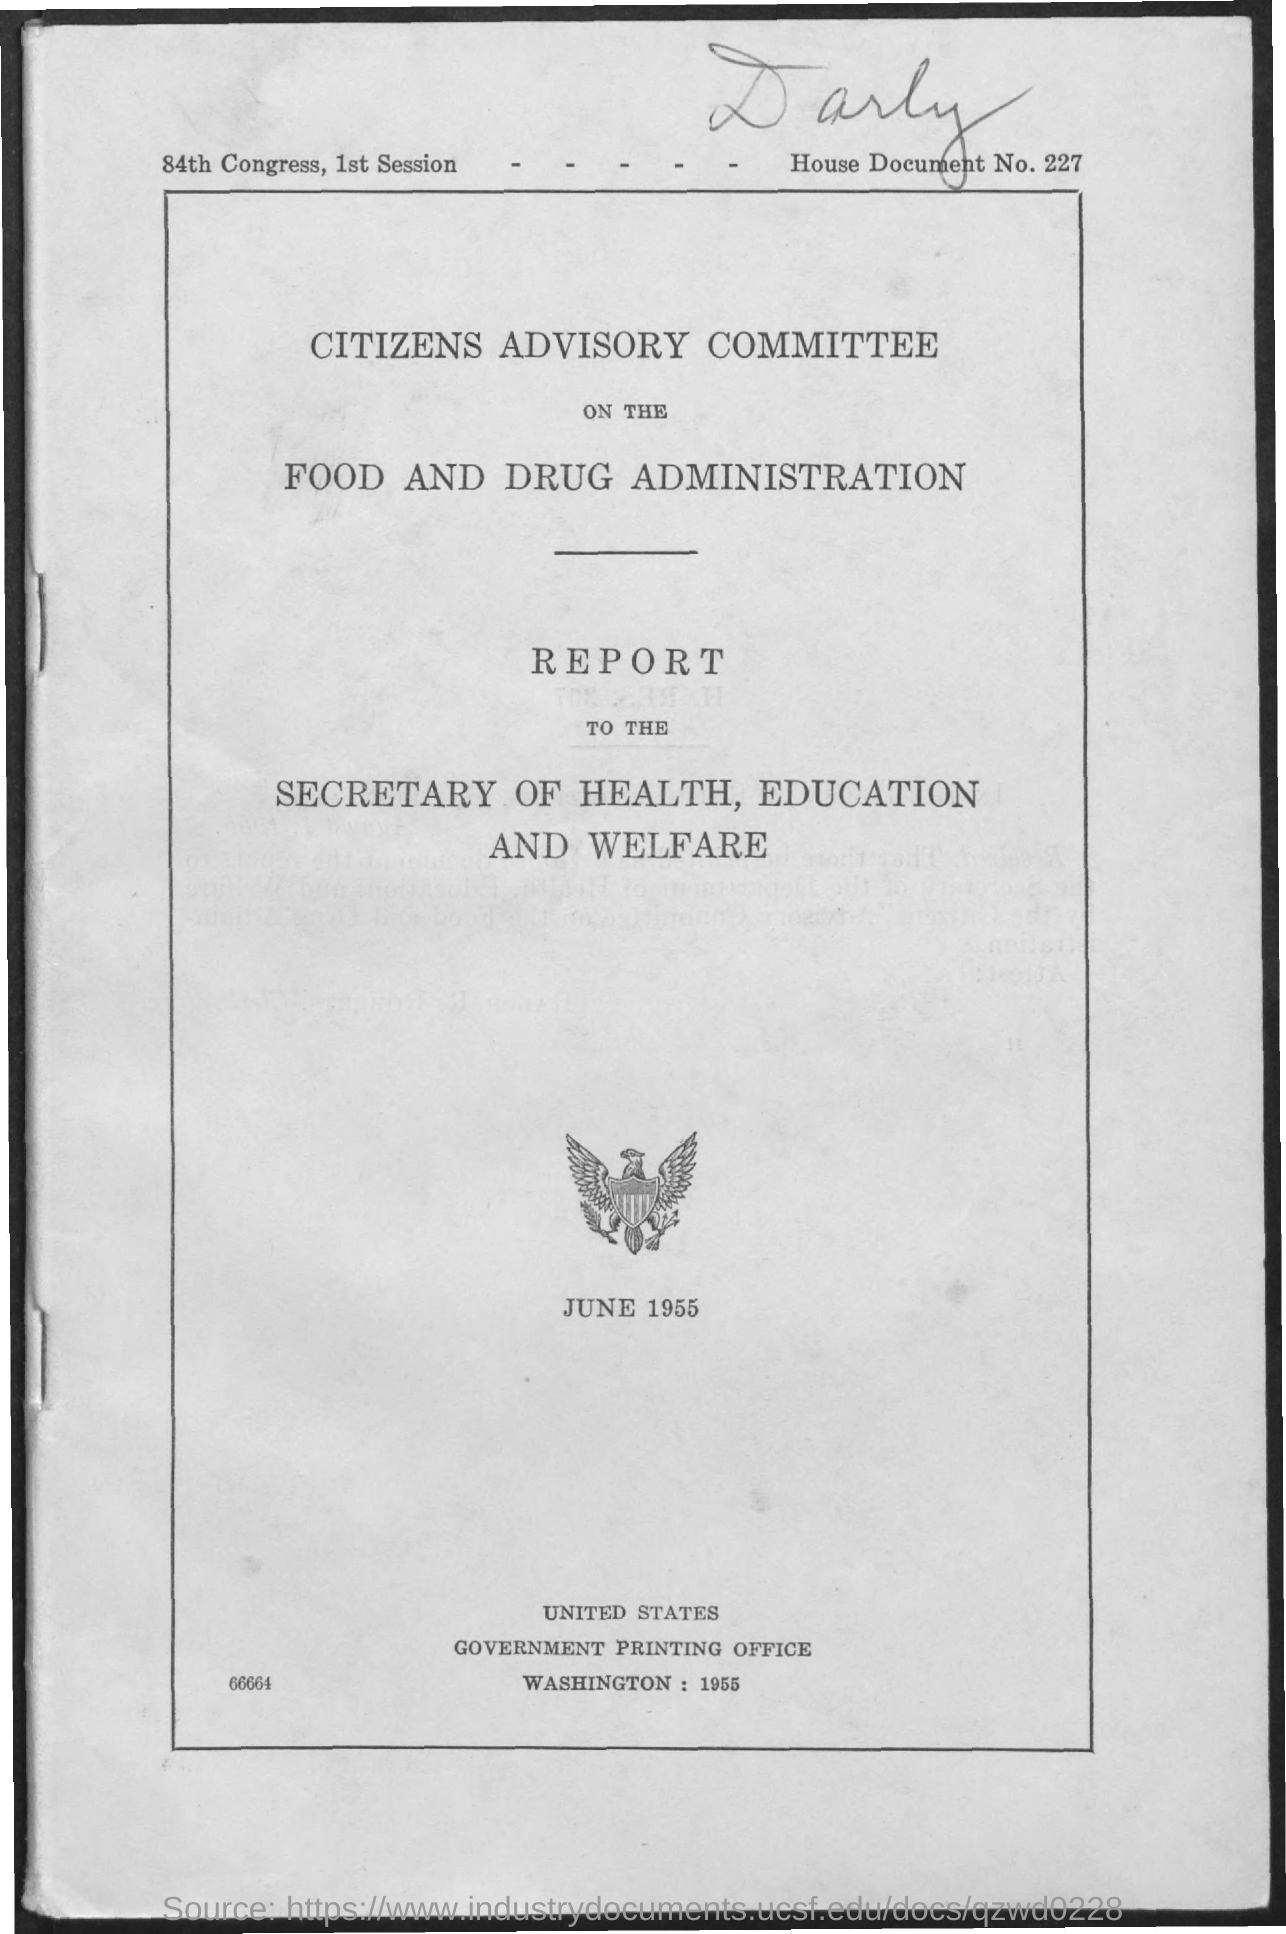Indicate a few pertinent items in this graphic. The document indicates that the date is June 1955. The House document number is 227. 